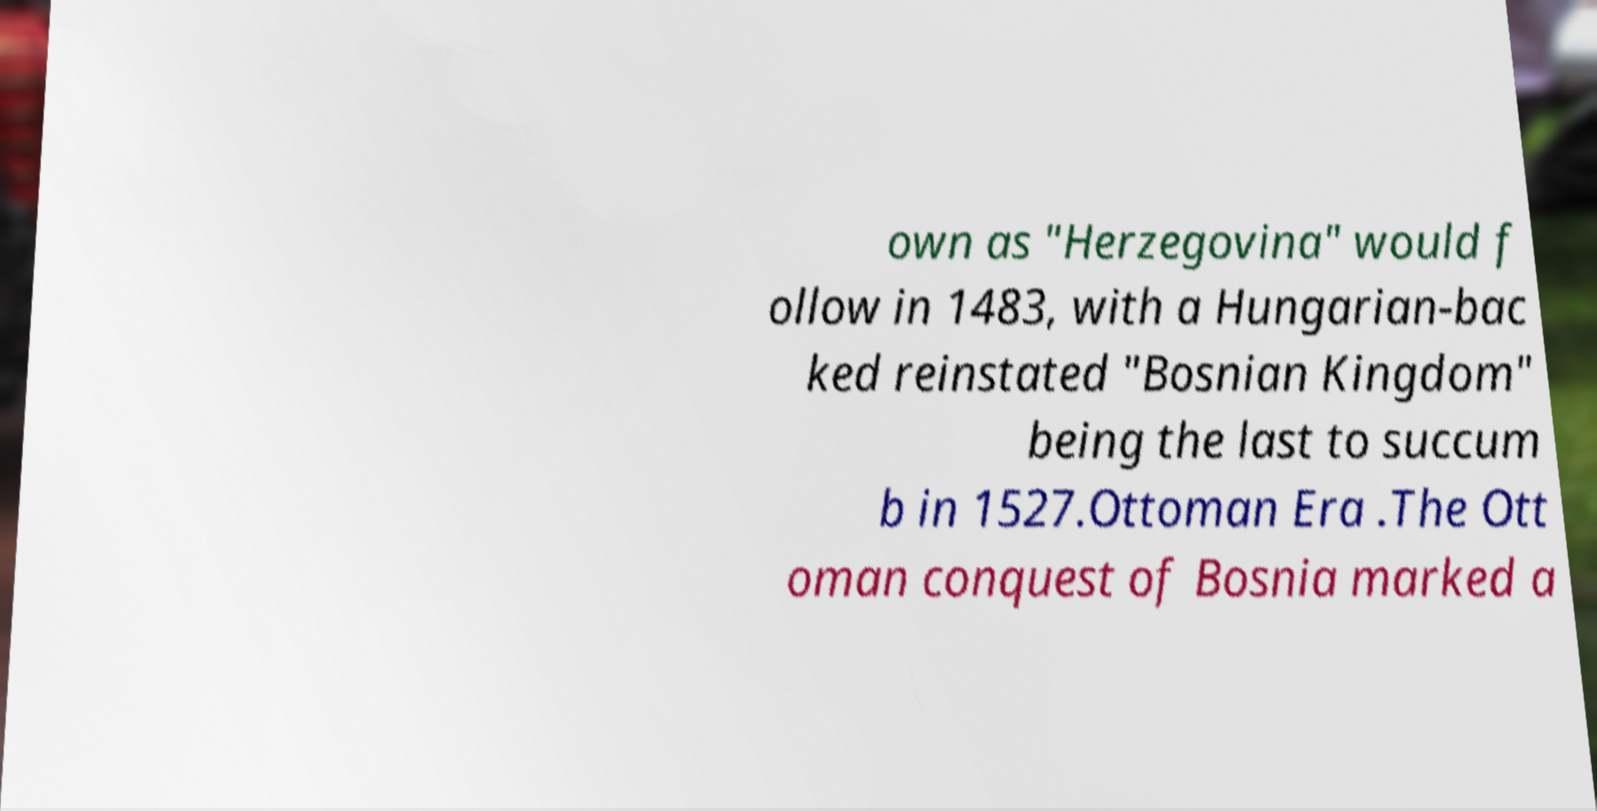I need the written content from this picture converted into text. Can you do that? own as "Herzegovina" would f ollow in 1483, with a Hungarian-bac ked reinstated "Bosnian Kingdom" being the last to succum b in 1527.Ottoman Era .The Ott oman conquest of Bosnia marked a 